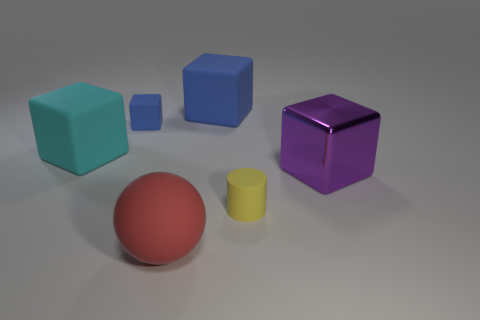If these objects represented a family, which one would be the parent, and which ones the children? If we were to anthropomorphize the objects, the largest object, perhaps the teal cube, could represent the parent due to its size and central placement. The smaller objects, like the small blue cube, the royal blue square, and the yellow cylinder, could be seen as the children clustered nearby. 